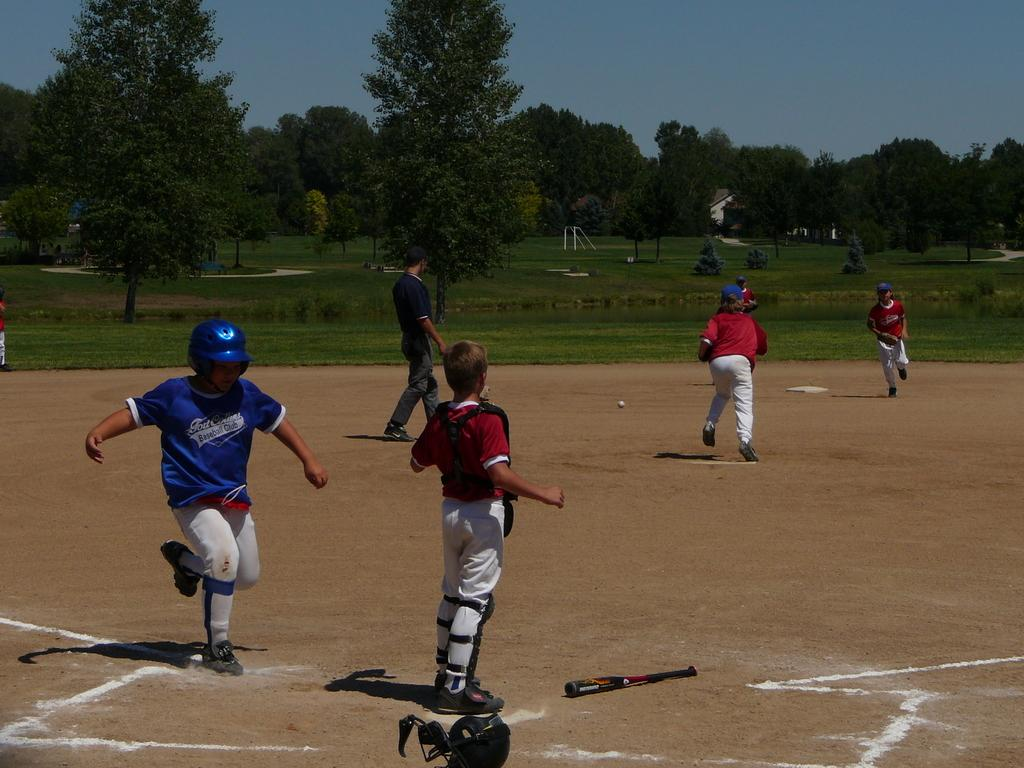<image>
Provide a brief description of the given image. a boy in a Baseball Club shirt runs to home plate 